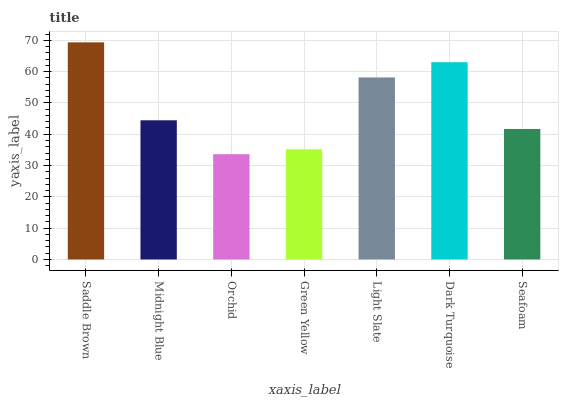Is Orchid the minimum?
Answer yes or no. Yes. Is Saddle Brown the maximum?
Answer yes or no. Yes. Is Midnight Blue the minimum?
Answer yes or no. No. Is Midnight Blue the maximum?
Answer yes or no. No. Is Saddle Brown greater than Midnight Blue?
Answer yes or no. Yes. Is Midnight Blue less than Saddle Brown?
Answer yes or no. Yes. Is Midnight Blue greater than Saddle Brown?
Answer yes or no. No. Is Saddle Brown less than Midnight Blue?
Answer yes or no. No. Is Midnight Blue the high median?
Answer yes or no. Yes. Is Midnight Blue the low median?
Answer yes or no. Yes. Is Dark Turquoise the high median?
Answer yes or no. No. Is Orchid the low median?
Answer yes or no. No. 